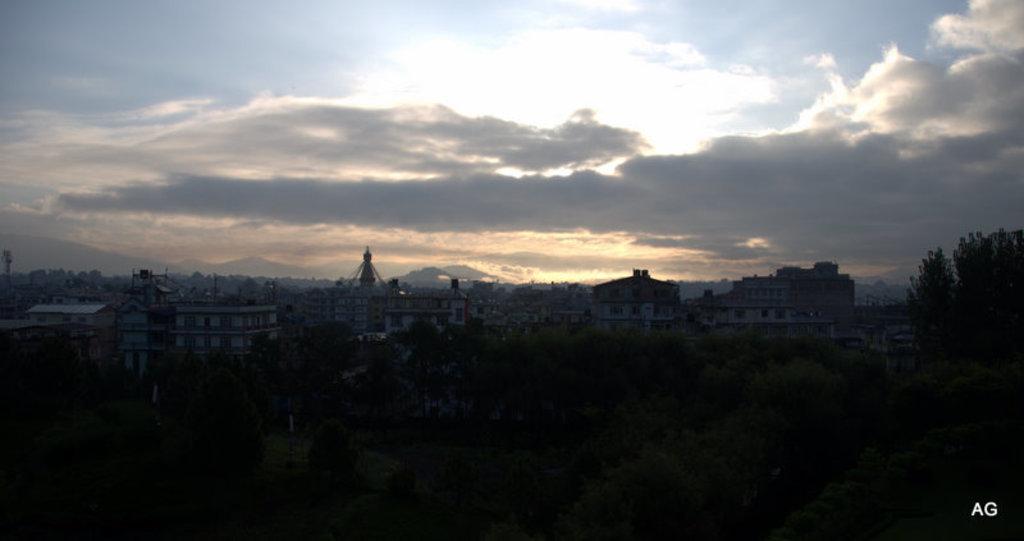Describe this image in one or two sentences. In this image I can see the sky and I can see building and trees and at the bottom I can see picture is very dark. 